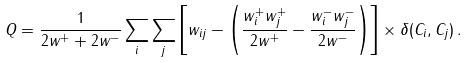<formula> <loc_0><loc_0><loc_500><loc_500>Q = \frac { 1 } { 2 w ^ { + } + 2 w ^ { - } } \sum _ { i } \sum _ { j } \left [ w _ { i j } - \left ( \frac { w _ { i } ^ { + } w _ { j } ^ { + } } { 2 w ^ { + } } - \frac { w _ { i } ^ { - } w _ { j } ^ { - } } { 2 w ^ { - } } \right ) \right ] \times \delta ( C _ { i } , C _ { j } ) \, .</formula> 